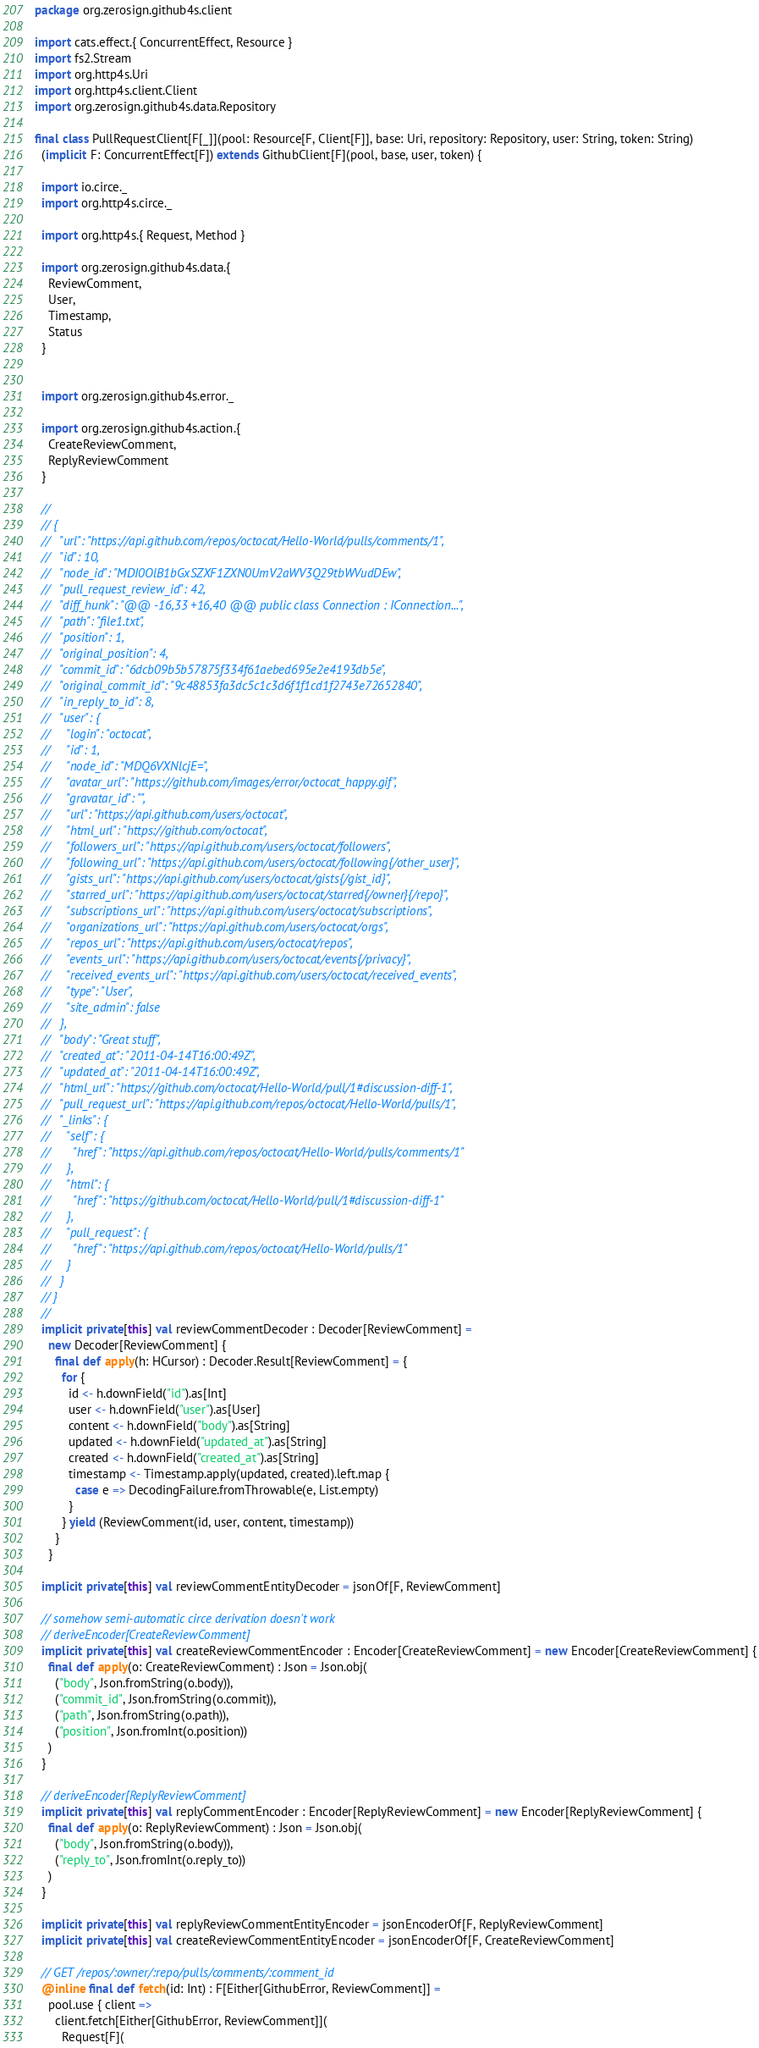Convert code to text. <code><loc_0><loc_0><loc_500><loc_500><_Scala_>package org.zerosign.github4s.client

import cats.effect.{ ConcurrentEffect, Resource }
import fs2.Stream
import org.http4s.Uri
import org.http4s.client.Client
import org.zerosign.github4s.data.Repository

final class PullRequestClient[F[_]](pool: Resource[F, Client[F]], base: Uri, repository: Repository, user: String, token: String)
  (implicit F: ConcurrentEffect[F]) extends GithubClient[F](pool, base, user, token) {

  import io.circe._
  import org.http4s.circe._

  import org.http4s.{ Request, Method }

  import org.zerosign.github4s.data.{
    ReviewComment,
    User,
    Timestamp,
    Status
  }


  import org.zerosign.github4s.error._

  import org.zerosign.github4s.action.{
    CreateReviewComment,
    ReplyReviewComment
  }

  //
  // {
  //   "url": "https://api.github.com/repos/octocat/Hello-World/pulls/comments/1",
  //   "id": 10,
  //   "node_id": "MDI0OlB1bGxSZXF1ZXN0UmV2aWV3Q29tbWVudDEw",
  //   "pull_request_review_id": 42,
  //   "diff_hunk": "@@ -16,33 +16,40 @@ public class Connection : IConnection...",
  //   "path": "file1.txt",
  //   "position": 1,
  //   "original_position": 4,
  //   "commit_id": "6dcb09b5b57875f334f61aebed695e2e4193db5e",
  //   "original_commit_id": "9c48853fa3dc5c1c3d6f1f1cd1f2743e72652840",
  //   "in_reply_to_id": 8,
  //   "user": {
  //     "login": "octocat",
  //     "id": 1,
  //     "node_id": "MDQ6VXNlcjE=",
  //     "avatar_url": "https://github.com/images/error/octocat_happy.gif",
  //     "gravatar_id": "",
  //     "url": "https://api.github.com/users/octocat",
  //     "html_url": "https://github.com/octocat",
  //     "followers_url": "https://api.github.com/users/octocat/followers",
  //     "following_url": "https://api.github.com/users/octocat/following{/other_user}",
  //     "gists_url": "https://api.github.com/users/octocat/gists{/gist_id}",
  //     "starred_url": "https://api.github.com/users/octocat/starred{/owner}{/repo}",
  //     "subscriptions_url": "https://api.github.com/users/octocat/subscriptions",
  //     "organizations_url": "https://api.github.com/users/octocat/orgs",
  //     "repos_url": "https://api.github.com/users/octocat/repos",
  //     "events_url": "https://api.github.com/users/octocat/events{/privacy}",
  //     "received_events_url": "https://api.github.com/users/octocat/received_events",
  //     "type": "User",
  //     "site_admin": false
  //   },
  //   "body": "Great stuff",
  //   "created_at": "2011-04-14T16:00:49Z",
  //   "updated_at": "2011-04-14T16:00:49Z",
  //   "html_url": "https://github.com/octocat/Hello-World/pull/1#discussion-diff-1",
  //   "pull_request_url": "https://api.github.com/repos/octocat/Hello-World/pulls/1",
  //   "_links": {
  //     "self": {
  //       "href": "https://api.github.com/repos/octocat/Hello-World/pulls/comments/1"
  //     },
  //     "html": {
  //       "href": "https://github.com/octocat/Hello-World/pull/1#discussion-diff-1"
  //     },
  //     "pull_request": {
  //       "href": "https://api.github.com/repos/octocat/Hello-World/pulls/1"
  //     }
  //   }
  // }
  //
  implicit private[this] val reviewCommentDecoder : Decoder[ReviewComment] =
    new Decoder[ReviewComment] {
      final def apply(h: HCursor) : Decoder.Result[ReviewComment] = {
        for {
          id <- h.downField("id").as[Int]
          user <- h.downField("user").as[User]
          content <- h.downField("body").as[String]
          updated <- h.downField("updated_at").as[String]
          created <- h.downField("created_at").as[String]
          timestamp <- Timestamp.apply(updated, created).left.map {
            case e => DecodingFailure.fromThrowable(e, List.empty)
          }
        } yield (ReviewComment(id, user, content, timestamp))
      }
    }

  implicit private[this] val reviewCommentEntityDecoder = jsonOf[F, ReviewComment]

  // somehow semi-automatic circe derivation doesn't work
  // deriveEncoder[CreateReviewComment]
  implicit private[this] val createReviewCommentEncoder : Encoder[CreateReviewComment] = new Encoder[CreateReviewComment] {
    final def apply(o: CreateReviewComment) : Json = Json.obj(
      ("body", Json.fromString(o.body)),
      ("commit_id", Json.fromString(o.commit)),
      ("path", Json.fromString(o.path)),
      ("position", Json.fromInt(o.position))
    )
  }

  // deriveEncoder[ReplyReviewComment]
  implicit private[this] val replyCommentEncoder : Encoder[ReplyReviewComment] = new Encoder[ReplyReviewComment] {
    final def apply(o: ReplyReviewComment) : Json = Json.obj(
      ("body", Json.fromString(o.body)),
      ("reply_to", Json.fromInt(o.reply_to))
    )
  }

  implicit private[this] val replyReviewCommentEntityEncoder = jsonEncoderOf[F, ReplyReviewComment]
  implicit private[this] val createReviewCommentEntityEncoder = jsonEncoderOf[F, CreateReviewComment]

  // GET /repos/:owner/:repo/pulls/comments/:comment_id
  @inline final def fetch(id: Int) : F[Either[GithubError, ReviewComment]] =
    pool.use { client =>
      client.fetch[Either[GithubError, ReviewComment]](
        Request[F](</code> 